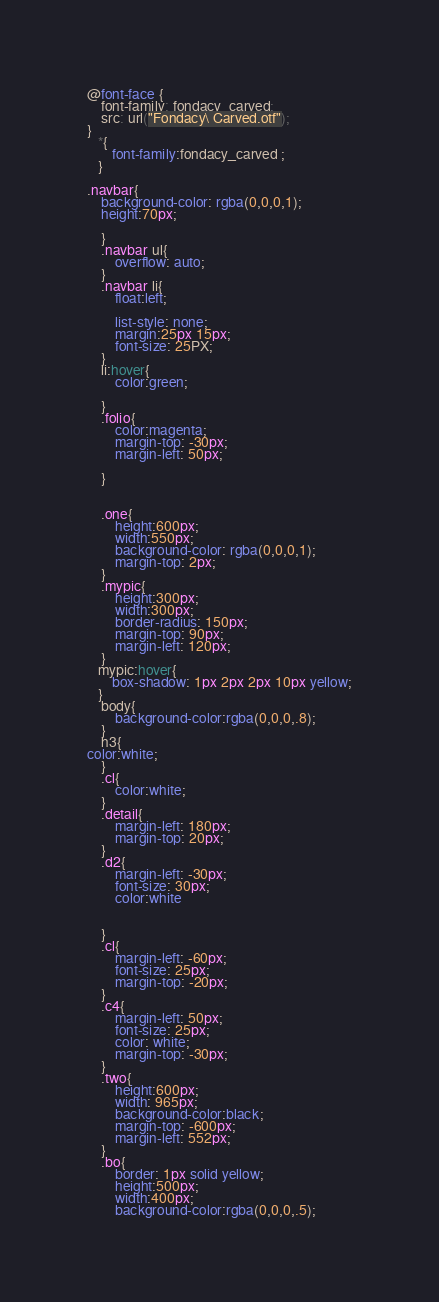Convert code to text. <code><loc_0><loc_0><loc_500><loc_500><_CSS_>@font-face {
    font-family: fondacy_carved;
    src: url("Fondacy\ Carved.otf");
}
   *{
       font-family:fondacy_carved ;
   }

.navbar{
    background-color: rgba(0,0,0,1);
    height:70px;
    
    }
    .navbar ul{
        overflow: auto;
    }
    .navbar li{
        float:left;
       
        list-style: none;
        margin:25px 15px;
        font-size: 25PX;
    }
    li:hover{
        color:green;

    }
    .folio{
        color:magenta;
        margin-top: -30px;
        margin-left: 50px;

    }
    
  
    .one{
        height:600px;
        width:550px;
        background-color: rgba(0,0,0,1);
        margin-top: 2px;
    }
    .mypic{
        height:300px;
        width:300px;
        border-radius: 150px;
        margin-top: 90px;
        margin-left: 120px;
    }
   mypic:hover{
       box-shadow: 1px 2px 2px 10px yellow;
   }
    body{
        background-color:rgba(0,0,0,.8);
    }
    h3{
color:white;
    }
    .cl{
        color:white;
    }
    .detail{
        margin-left: 180px;
        margin-top: 20px;
    }
    .d2{
        margin-left: -30px;
        font-size: 30px;
        color:white
        

    }
    .cl{
        margin-left: -60px;
        font-size: 25px;
        margin-top: -20px;
    }
    .c4{
        margin-left: 50px;
        font-size: 25px;
        color: white;
        margin-top: -30px;
    }
    .two{
        height:600px;
        width: 965px;
        background-color:black;
        margin-top: -600px;
        margin-left: 552px;
    }
    .bo{
        border: 1px solid yellow;
        height:500px;
        width:400px;
        background-color:rgba(0,0,0,.5);</code> 